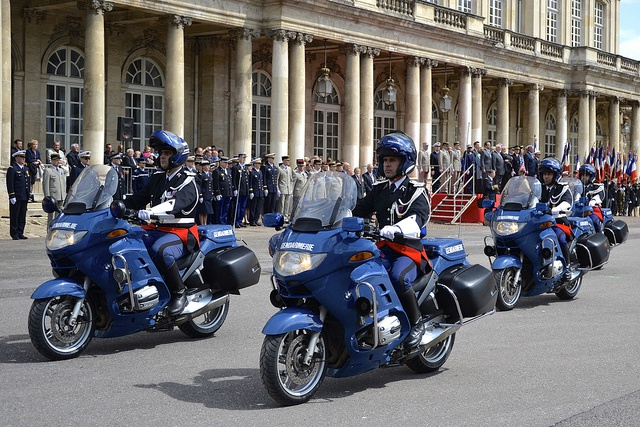Describe the objects in this image and their specific colors. I can see motorcycle in lightgray, black, navy, gray, and darkgray tones, motorcycle in lightgray, black, navy, gray, and blue tones, people in lightgray, black, gray, darkgray, and navy tones, motorcycle in lightgray, black, navy, gray, and darkgray tones, and people in lightgray, black, navy, white, and gray tones in this image. 